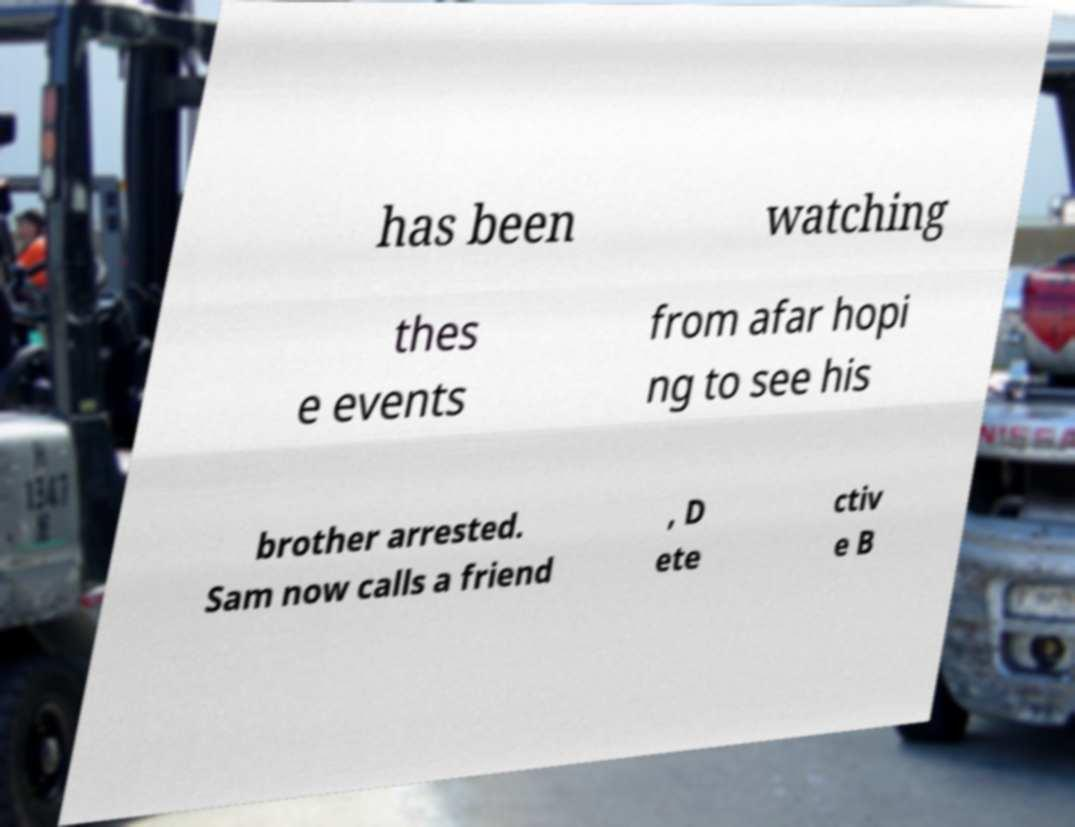There's text embedded in this image that I need extracted. Can you transcribe it verbatim? has been watching thes e events from afar hopi ng to see his brother arrested. Sam now calls a friend , D ete ctiv e B 